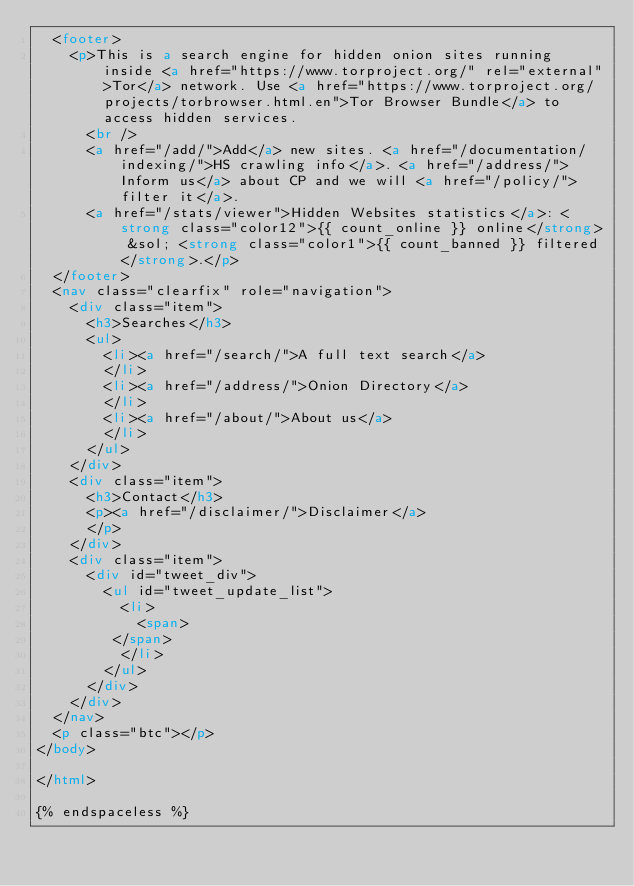Convert code to text. <code><loc_0><loc_0><loc_500><loc_500><_HTML_>  <footer>
    <p>This is a search engine for hidden onion sites running inside <a href="https://www.torproject.org/" rel="external">Tor</a> network. Use <a href="https://www.torproject.org/projects/torbrowser.html.en">Tor Browser Bundle</a> to access hidden services.
      <br />
      <a href="/add/">Add</a> new sites. <a href="/documentation/indexing/">HS crawling info</a>. <a href="/address/">Inform us</a> about CP and we will <a href="/policy/">filter it</a>.
      <a href="/stats/viewer">Hidden Websites statistics</a>: <strong class="color12">{{ count_online }} online</strong> &sol; <strong class="color1">{{ count_banned }} filtered</strong>.</p>
  </footer>
  <nav class="clearfix" role="navigation">
    <div class="item">
      <h3>Searches</h3>
      <ul>
        <li><a href="/search/">A full text search</a>
        </li>
        <li><a href="/address/">Onion Directory</a>
        </li>
        <li><a href="/about/">About us</a>
        </li>
      </ul>
    </div>
    <div class="item">
      <h3>Contact</h3>
      <p><a href="/disclaimer/">Disclaimer</a>
      </p>
    </div>
    <div class="item">
      <div id="tweet_div">
        <ul id="tweet_update_list">
          <li>
            <span>
         </span>
          </li>
        </ul>
      </div>
    </div>
  </nav>
  <p class="btc"></p>
</body>

</html>

{% endspaceless %}
</code> 